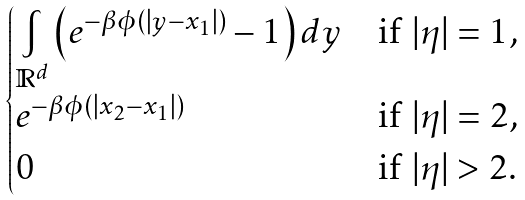<formula> <loc_0><loc_0><loc_500><loc_500>\begin{cases} \underset { \mathbb { R } ^ { d } } { \int } \left ( e ^ { - \beta \phi ( | y - x _ { 1 } | ) } - 1 \right ) d y & \text {if $|\eta|=1$,} \\ e ^ { - \beta \phi ( | x _ { 2 } - x _ { 1 } | ) } & \text {if $|\eta|=2$,} \\ 0 & \text {if $|\eta|>2$.} \end{cases}</formula> 